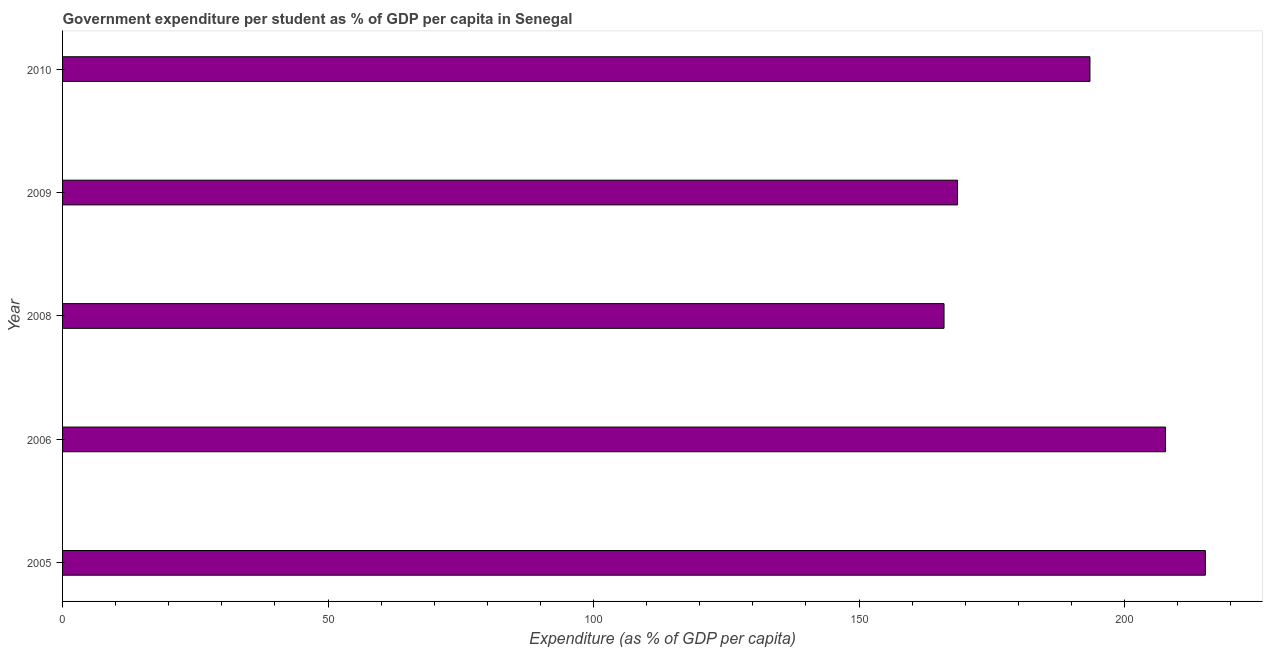What is the title of the graph?
Your response must be concise. Government expenditure per student as % of GDP per capita in Senegal. What is the label or title of the X-axis?
Offer a terse response. Expenditure (as % of GDP per capita). What is the label or title of the Y-axis?
Offer a terse response. Year. What is the government expenditure per student in 2006?
Provide a succinct answer. 207.71. Across all years, what is the maximum government expenditure per student?
Ensure brevity in your answer.  215.21. Across all years, what is the minimum government expenditure per student?
Your answer should be compact. 166. In which year was the government expenditure per student maximum?
Your answer should be very brief. 2005. What is the sum of the government expenditure per student?
Offer a very short reply. 950.94. What is the difference between the government expenditure per student in 2006 and 2008?
Keep it short and to the point. 41.72. What is the average government expenditure per student per year?
Make the answer very short. 190.19. What is the median government expenditure per student?
Give a very brief answer. 193.48. Do a majority of the years between 2008 and 2005 (inclusive) have government expenditure per student greater than 190 %?
Give a very brief answer. Yes. What is the ratio of the government expenditure per student in 2005 to that in 2009?
Provide a succinct answer. 1.28. Is the government expenditure per student in 2006 less than that in 2008?
Ensure brevity in your answer.  No. What is the difference between the highest and the second highest government expenditure per student?
Your response must be concise. 7.5. Is the sum of the government expenditure per student in 2006 and 2008 greater than the maximum government expenditure per student across all years?
Offer a very short reply. Yes. What is the difference between the highest and the lowest government expenditure per student?
Your answer should be very brief. 49.21. In how many years, is the government expenditure per student greater than the average government expenditure per student taken over all years?
Your response must be concise. 3. How many bars are there?
Ensure brevity in your answer.  5. How many years are there in the graph?
Offer a very short reply. 5. What is the difference between two consecutive major ticks on the X-axis?
Provide a short and direct response. 50. What is the Expenditure (as % of GDP per capita) of 2005?
Provide a short and direct response. 215.21. What is the Expenditure (as % of GDP per capita) in 2006?
Provide a short and direct response. 207.71. What is the Expenditure (as % of GDP per capita) of 2008?
Ensure brevity in your answer.  166. What is the Expenditure (as % of GDP per capita) of 2009?
Give a very brief answer. 168.54. What is the Expenditure (as % of GDP per capita) of 2010?
Your answer should be very brief. 193.48. What is the difference between the Expenditure (as % of GDP per capita) in 2005 and 2006?
Your answer should be very brief. 7.5. What is the difference between the Expenditure (as % of GDP per capita) in 2005 and 2008?
Make the answer very short. 49.21. What is the difference between the Expenditure (as % of GDP per capita) in 2005 and 2009?
Provide a short and direct response. 46.67. What is the difference between the Expenditure (as % of GDP per capita) in 2005 and 2010?
Ensure brevity in your answer.  21.73. What is the difference between the Expenditure (as % of GDP per capita) in 2006 and 2008?
Provide a short and direct response. 41.72. What is the difference between the Expenditure (as % of GDP per capita) in 2006 and 2009?
Provide a succinct answer. 39.17. What is the difference between the Expenditure (as % of GDP per capita) in 2006 and 2010?
Offer a very short reply. 14.24. What is the difference between the Expenditure (as % of GDP per capita) in 2008 and 2009?
Keep it short and to the point. -2.55. What is the difference between the Expenditure (as % of GDP per capita) in 2008 and 2010?
Offer a terse response. -27.48. What is the difference between the Expenditure (as % of GDP per capita) in 2009 and 2010?
Offer a terse response. -24.93. What is the ratio of the Expenditure (as % of GDP per capita) in 2005 to that in 2006?
Make the answer very short. 1.04. What is the ratio of the Expenditure (as % of GDP per capita) in 2005 to that in 2008?
Your response must be concise. 1.3. What is the ratio of the Expenditure (as % of GDP per capita) in 2005 to that in 2009?
Provide a succinct answer. 1.28. What is the ratio of the Expenditure (as % of GDP per capita) in 2005 to that in 2010?
Your response must be concise. 1.11. What is the ratio of the Expenditure (as % of GDP per capita) in 2006 to that in 2008?
Make the answer very short. 1.25. What is the ratio of the Expenditure (as % of GDP per capita) in 2006 to that in 2009?
Ensure brevity in your answer.  1.23. What is the ratio of the Expenditure (as % of GDP per capita) in 2006 to that in 2010?
Give a very brief answer. 1.07. What is the ratio of the Expenditure (as % of GDP per capita) in 2008 to that in 2010?
Offer a terse response. 0.86. What is the ratio of the Expenditure (as % of GDP per capita) in 2009 to that in 2010?
Ensure brevity in your answer.  0.87. 